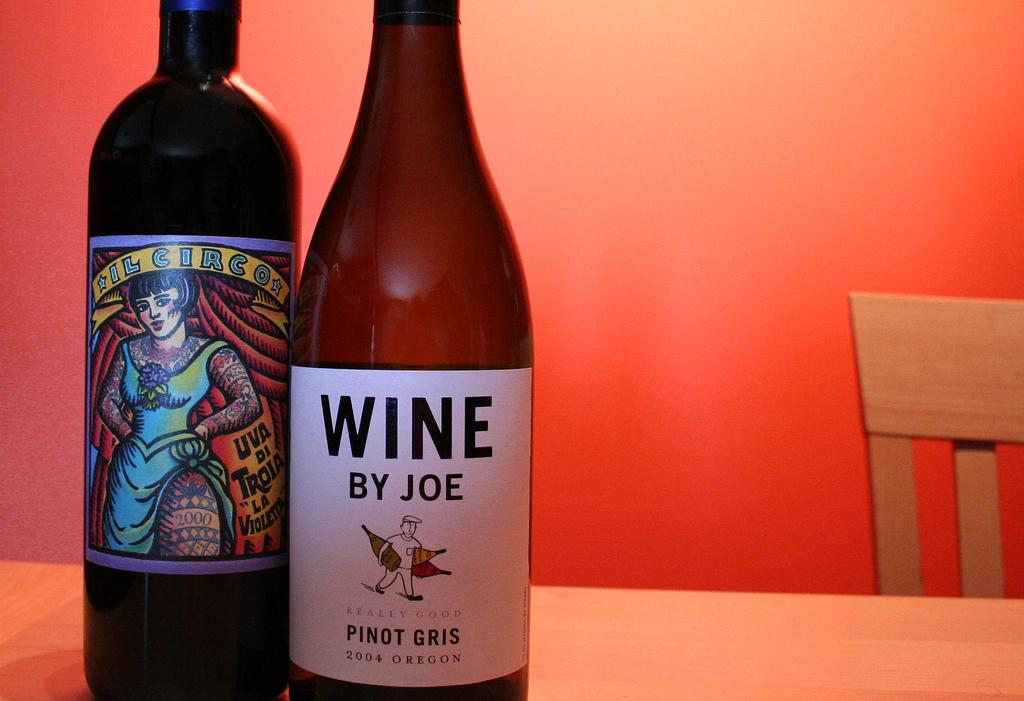Provide a one-sentence caption for the provided image. Two wind bottles sit side by side, on with a colorful label, the other with a plainer label for Wine by Joe. 